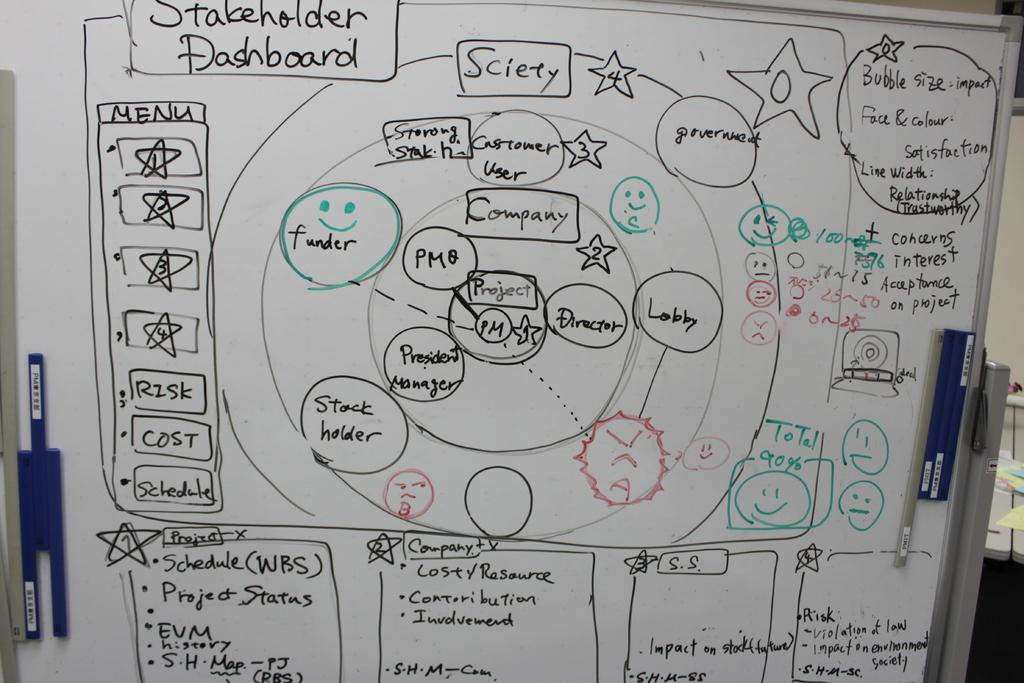<image>
Share a concise interpretation of the image provided. A whiteboard covered with different data displays is titled Stakeholder Dashboard. 